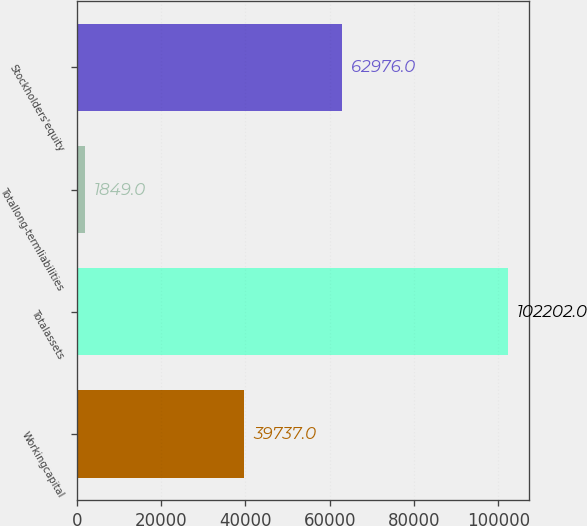Convert chart. <chart><loc_0><loc_0><loc_500><loc_500><bar_chart><fcel>Workingcapital<fcel>Totalassets<fcel>Totallong-termliabilities<fcel>Stockholders'equity<nl><fcel>39737<fcel>102202<fcel>1849<fcel>62976<nl></chart> 